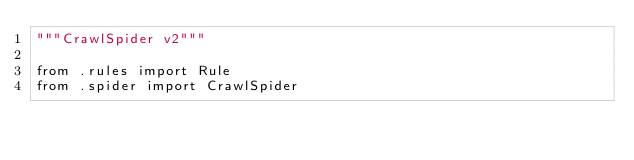<code> <loc_0><loc_0><loc_500><loc_500><_Python_>"""CrawlSpider v2"""

from .rules import Rule
from .spider import CrawlSpider
</code> 